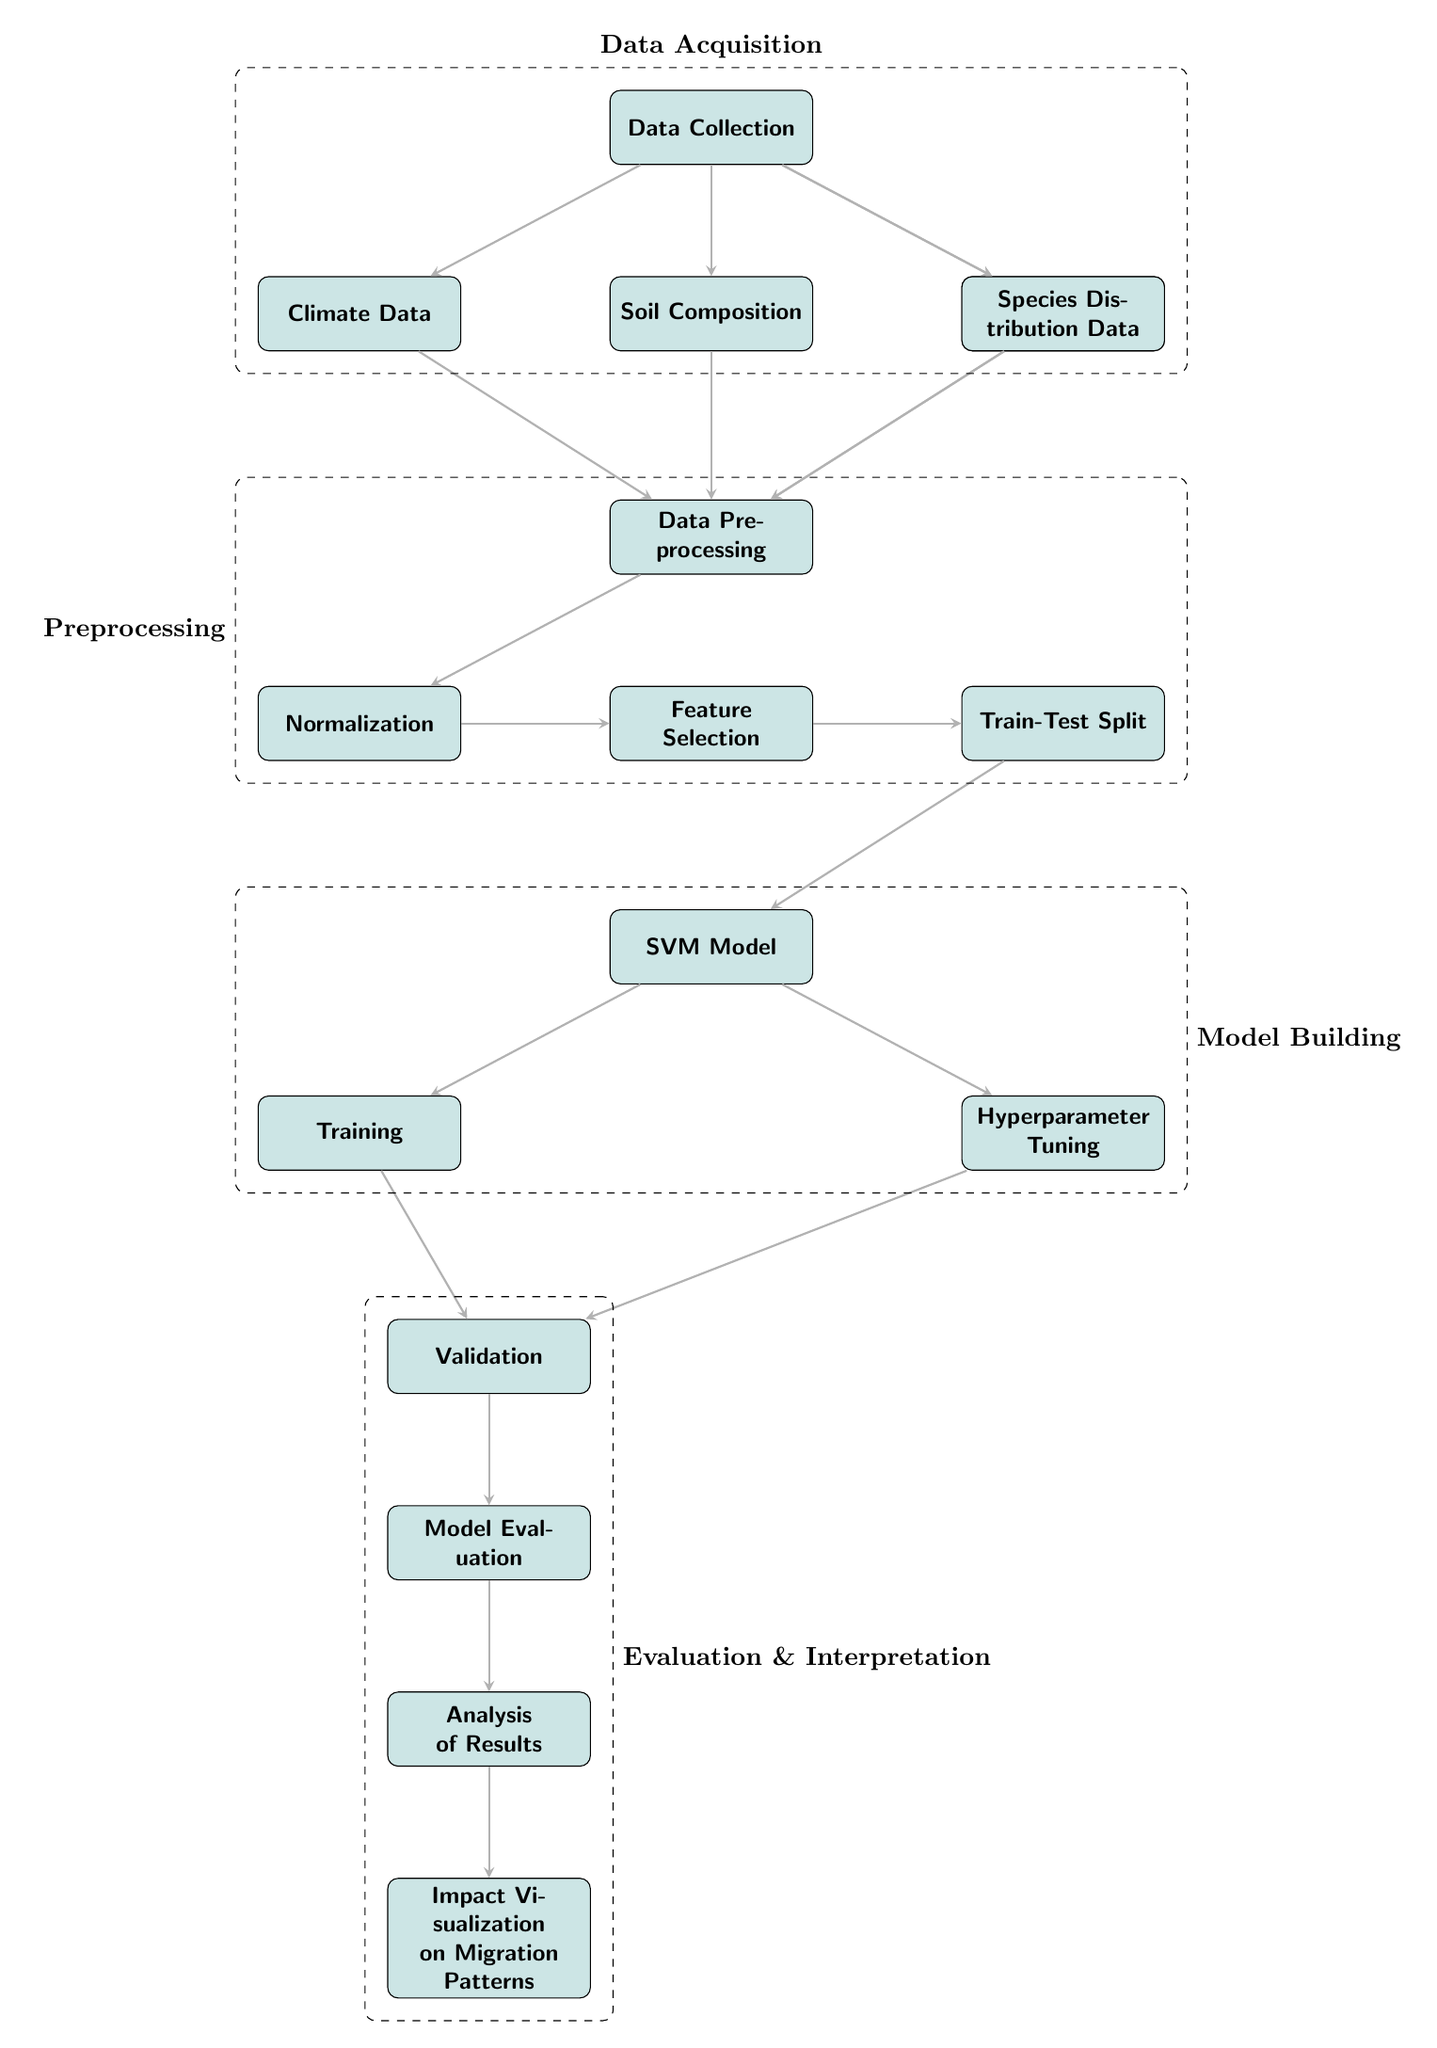What are the main components involved in Data Acquisition? The main components are Data Collection, Climate Data, Soil Composition, Altitude, and Species Distribution Data, all of which are encapsulated in the dashed box labeled "Data Acquisition".
Answer: Data Collection, Climate Data, Soil Composition, Altitude, Species Distribution Data How many nodes represent the preprocessing steps? The preprocessing steps include Data Preprocessing, Normalization, Feature Selection, and Train-Test Split, which adds up to four nodes.
Answer: Four What does the SVM model connect to after the Train-Test Split? After the Train-Test Split, the SVM Model connects directly to the Training node, indicating the start of model training.
Answer: Training Which components are included in the Evaluation & Interpretation phase? The components in this phase are Validation, Model Evaluation, Results, and Impact Visualization, all fitting within the dashed box labeled "Evaluation & Interpretation".
Answer: Validation, Model Evaluation, Results, Impact Visualization How does the Hyperparameter Tuning relate to Validation? The Hyperparameter Tuning is connected to the Validation node, indicating that tuning of hyperparameters occurs prior to or in conjunction with validation of the model.
Answer: It is connected; Hyperparameter Tuning leads to Validation What process comes after the SVM Model in the diagram? The processes following the SVM Model are Training and Hyperparameter Tuning, from which both lead to Validation.
Answer: Training and Hyperparameter Tuning Which node is a prerequisite for Feature Selection? Normalization is the prerequisite for Feature Selection according to the diagram's flow; it indicates that data must be normalized before selecting features.
Answer: Normalization How many paths lead from Data Preprocessing to SVM Model? There is one direct path from Data Preprocessing to the SVM Model, signifying that all preprocessing steps are completed before this point.
Answer: One Which nodes could be part of Impact Visualization? The node Impact Visualization connects directly to the Results, indicating that results from the SVM model are visualized to analyze impacts on migration patterns.
Answer: Results 